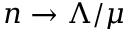Convert formula to latex. <formula><loc_0><loc_0><loc_500><loc_500>n \to \Lambda / \mu</formula> 